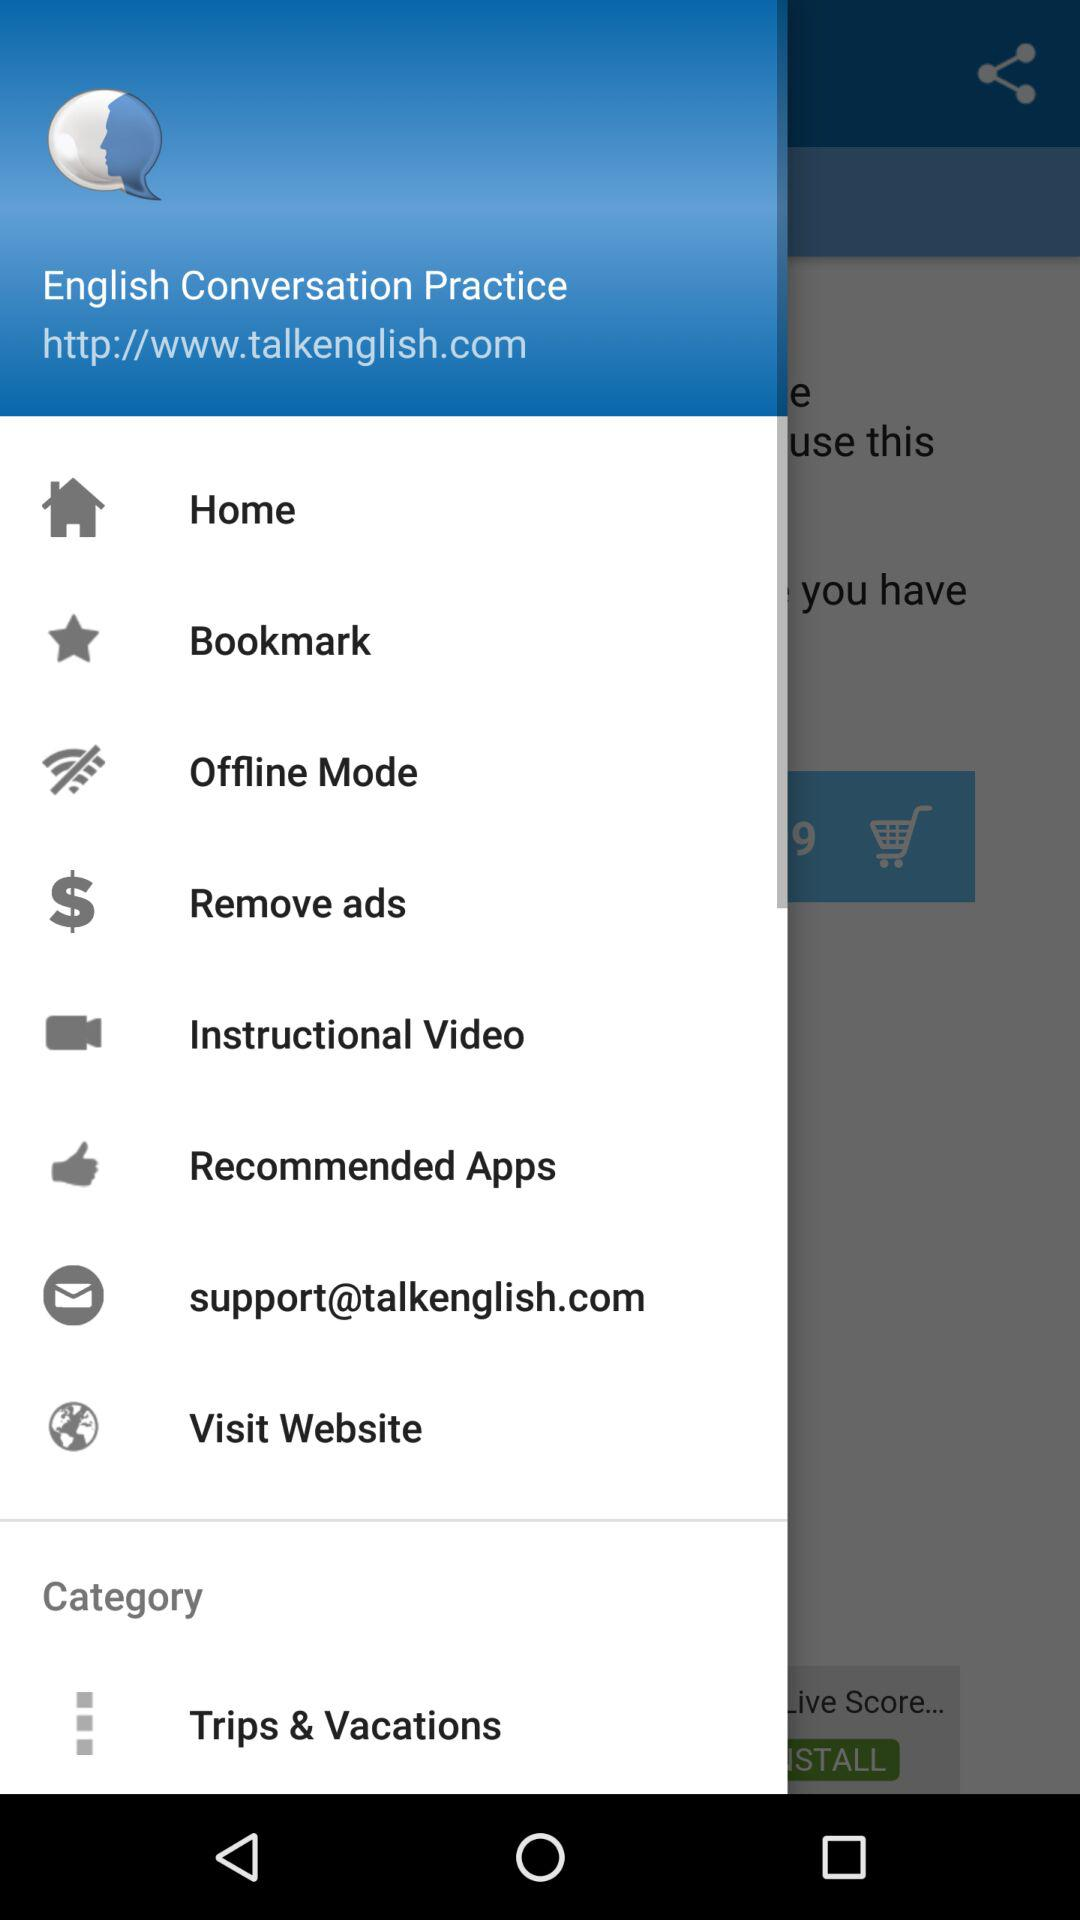What website can I visit for "English Conversation Practice"? The website is http://www.talkenglish.com. 